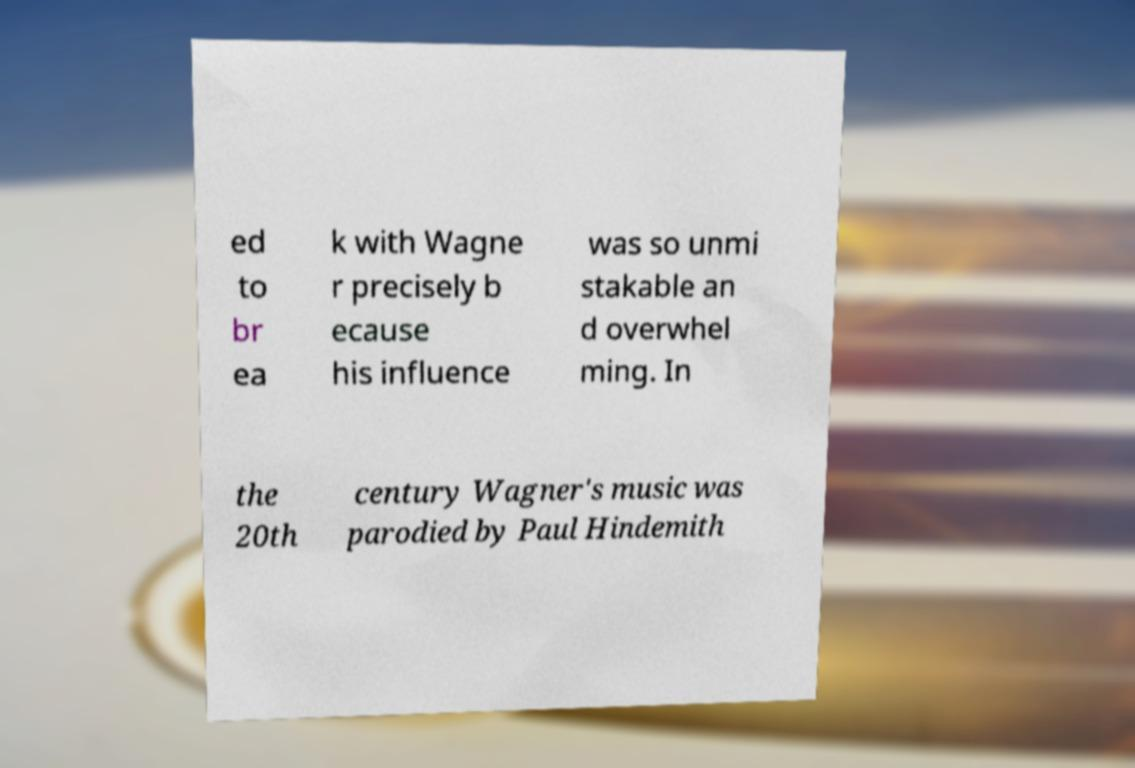Could you extract and type out the text from this image? ed to br ea k with Wagne r precisely b ecause his influence was so unmi stakable an d overwhel ming. In the 20th century Wagner's music was parodied by Paul Hindemith 